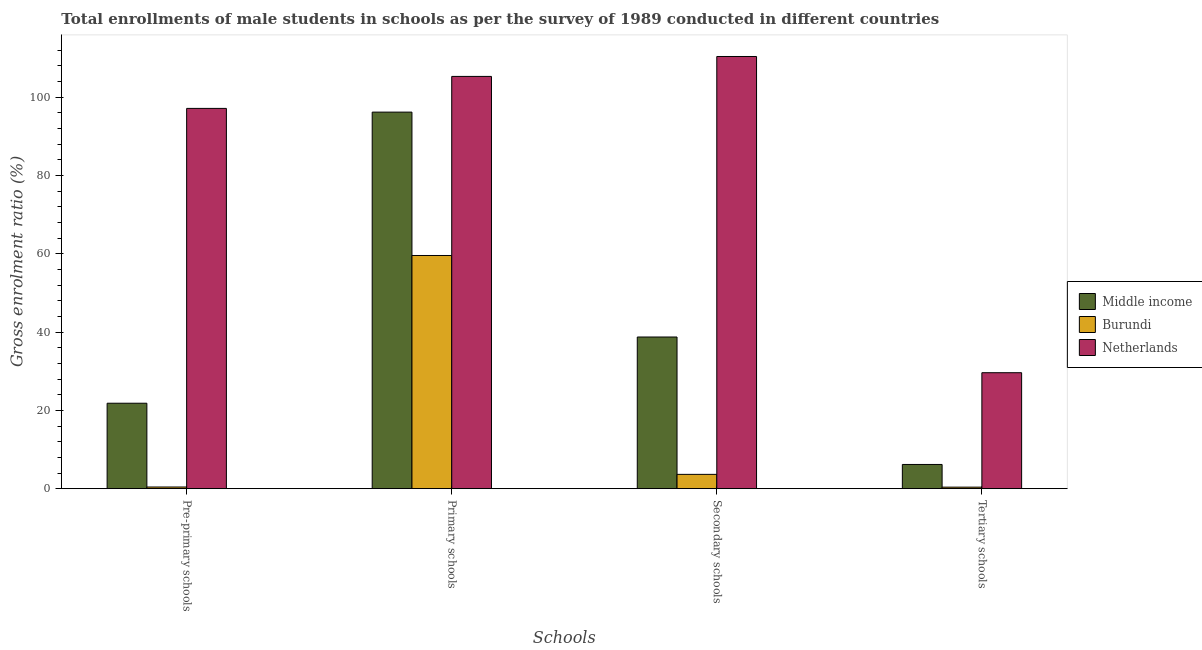How many different coloured bars are there?
Your answer should be very brief. 3. How many groups of bars are there?
Provide a short and direct response. 4. Are the number of bars per tick equal to the number of legend labels?
Your answer should be compact. Yes. Are the number of bars on each tick of the X-axis equal?
Ensure brevity in your answer.  Yes. How many bars are there on the 2nd tick from the left?
Make the answer very short. 3. How many bars are there on the 2nd tick from the right?
Offer a terse response. 3. What is the label of the 4th group of bars from the left?
Provide a short and direct response. Tertiary schools. What is the gross enrolment ratio(male) in pre-primary schools in Burundi?
Your answer should be very brief. 0.43. Across all countries, what is the maximum gross enrolment ratio(male) in pre-primary schools?
Give a very brief answer. 97.11. Across all countries, what is the minimum gross enrolment ratio(male) in secondary schools?
Your answer should be very brief. 3.65. In which country was the gross enrolment ratio(male) in secondary schools maximum?
Offer a terse response. Netherlands. In which country was the gross enrolment ratio(male) in tertiary schools minimum?
Give a very brief answer. Burundi. What is the total gross enrolment ratio(male) in tertiary schools in the graph?
Your answer should be very brief. 36.19. What is the difference between the gross enrolment ratio(male) in secondary schools in Netherlands and that in Burundi?
Offer a terse response. 106.71. What is the difference between the gross enrolment ratio(male) in tertiary schools in Burundi and the gross enrolment ratio(male) in secondary schools in Netherlands?
Provide a succinct answer. -109.97. What is the average gross enrolment ratio(male) in tertiary schools per country?
Provide a succinct answer. 12.06. What is the difference between the gross enrolment ratio(male) in secondary schools and gross enrolment ratio(male) in primary schools in Middle income?
Ensure brevity in your answer.  -57.43. In how many countries, is the gross enrolment ratio(male) in pre-primary schools greater than 8 %?
Your answer should be very brief. 2. What is the ratio of the gross enrolment ratio(male) in secondary schools in Middle income to that in Burundi?
Offer a very short reply. 10.6. What is the difference between the highest and the second highest gross enrolment ratio(male) in pre-primary schools?
Keep it short and to the point. 75.29. What is the difference between the highest and the lowest gross enrolment ratio(male) in primary schools?
Offer a terse response. 45.73. Is the sum of the gross enrolment ratio(male) in pre-primary schools in Burundi and Middle income greater than the maximum gross enrolment ratio(male) in tertiary schools across all countries?
Your response must be concise. No. Is it the case that in every country, the sum of the gross enrolment ratio(male) in pre-primary schools and gross enrolment ratio(male) in primary schools is greater than the gross enrolment ratio(male) in secondary schools?
Ensure brevity in your answer.  Yes. How many bars are there?
Keep it short and to the point. 12. How many countries are there in the graph?
Your response must be concise. 3. Are the values on the major ticks of Y-axis written in scientific E-notation?
Your answer should be compact. No. How many legend labels are there?
Ensure brevity in your answer.  3. What is the title of the graph?
Offer a terse response. Total enrollments of male students in schools as per the survey of 1989 conducted in different countries. What is the label or title of the X-axis?
Ensure brevity in your answer.  Schools. What is the Gross enrolment ratio (%) of Middle income in Pre-primary schools?
Ensure brevity in your answer.  21.82. What is the Gross enrolment ratio (%) of Burundi in Pre-primary schools?
Offer a terse response. 0.43. What is the Gross enrolment ratio (%) in Netherlands in Pre-primary schools?
Make the answer very short. 97.11. What is the Gross enrolment ratio (%) in Middle income in Primary schools?
Offer a terse response. 96.16. What is the Gross enrolment ratio (%) of Burundi in Primary schools?
Your answer should be compact. 59.55. What is the Gross enrolment ratio (%) in Netherlands in Primary schools?
Offer a very short reply. 105.28. What is the Gross enrolment ratio (%) in Middle income in Secondary schools?
Ensure brevity in your answer.  38.73. What is the Gross enrolment ratio (%) in Burundi in Secondary schools?
Your answer should be compact. 3.65. What is the Gross enrolment ratio (%) of Netherlands in Secondary schools?
Provide a succinct answer. 110.36. What is the Gross enrolment ratio (%) of Middle income in Tertiary schools?
Ensure brevity in your answer.  6.18. What is the Gross enrolment ratio (%) in Burundi in Tertiary schools?
Provide a succinct answer. 0.39. What is the Gross enrolment ratio (%) of Netherlands in Tertiary schools?
Offer a very short reply. 29.61. Across all Schools, what is the maximum Gross enrolment ratio (%) in Middle income?
Keep it short and to the point. 96.16. Across all Schools, what is the maximum Gross enrolment ratio (%) in Burundi?
Ensure brevity in your answer.  59.55. Across all Schools, what is the maximum Gross enrolment ratio (%) of Netherlands?
Provide a short and direct response. 110.36. Across all Schools, what is the minimum Gross enrolment ratio (%) of Middle income?
Ensure brevity in your answer.  6.18. Across all Schools, what is the minimum Gross enrolment ratio (%) of Burundi?
Your answer should be very brief. 0.39. Across all Schools, what is the minimum Gross enrolment ratio (%) of Netherlands?
Your response must be concise. 29.61. What is the total Gross enrolment ratio (%) in Middle income in the graph?
Your answer should be very brief. 162.89. What is the total Gross enrolment ratio (%) in Burundi in the graph?
Ensure brevity in your answer.  64.02. What is the total Gross enrolment ratio (%) in Netherlands in the graph?
Provide a short and direct response. 342.36. What is the difference between the Gross enrolment ratio (%) of Middle income in Pre-primary schools and that in Primary schools?
Your answer should be very brief. -74.34. What is the difference between the Gross enrolment ratio (%) in Burundi in Pre-primary schools and that in Primary schools?
Offer a terse response. -59.12. What is the difference between the Gross enrolment ratio (%) of Netherlands in Pre-primary schools and that in Primary schools?
Ensure brevity in your answer.  -8.17. What is the difference between the Gross enrolment ratio (%) in Middle income in Pre-primary schools and that in Secondary schools?
Offer a very short reply. -16.91. What is the difference between the Gross enrolment ratio (%) in Burundi in Pre-primary schools and that in Secondary schools?
Keep it short and to the point. -3.23. What is the difference between the Gross enrolment ratio (%) in Netherlands in Pre-primary schools and that in Secondary schools?
Ensure brevity in your answer.  -13.26. What is the difference between the Gross enrolment ratio (%) in Middle income in Pre-primary schools and that in Tertiary schools?
Your answer should be compact. 15.64. What is the difference between the Gross enrolment ratio (%) in Burundi in Pre-primary schools and that in Tertiary schools?
Offer a terse response. 0.04. What is the difference between the Gross enrolment ratio (%) of Netherlands in Pre-primary schools and that in Tertiary schools?
Provide a short and direct response. 67.49. What is the difference between the Gross enrolment ratio (%) in Middle income in Primary schools and that in Secondary schools?
Ensure brevity in your answer.  57.43. What is the difference between the Gross enrolment ratio (%) in Burundi in Primary schools and that in Secondary schools?
Your answer should be very brief. 55.89. What is the difference between the Gross enrolment ratio (%) in Netherlands in Primary schools and that in Secondary schools?
Make the answer very short. -5.09. What is the difference between the Gross enrolment ratio (%) in Middle income in Primary schools and that in Tertiary schools?
Make the answer very short. 89.98. What is the difference between the Gross enrolment ratio (%) in Burundi in Primary schools and that in Tertiary schools?
Your answer should be very brief. 59.16. What is the difference between the Gross enrolment ratio (%) in Netherlands in Primary schools and that in Tertiary schools?
Your response must be concise. 75.66. What is the difference between the Gross enrolment ratio (%) of Middle income in Secondary schools and that in Tertiary schools?
Offer a very short reply. 32.55. What is the difference between the Gross enrolment ratio (%) in Burundi in Secondary schools and that in Tertiary schools?
Make the answer very short. 3.26. What is the difference between the Gross enrolment ratio (%) of Netherlands in Secondary schools and that in Tertiary schools?
Your answer should be very brief. 80.75. What is the difference between the Gross enrolment ratio (%) in Middle income in Pre-primary schools and the Gross enrolment ratio (%) in Burundi in Primary schools?
Your answer should be very brief. -37.73. What is the difference between the Gross enrolment ratio (%) of Middle income in Pre-primary schools and the Gross enrolment ratio (%) of Netherlands in Primary schools?
Offer a very short reply. -83.45. What is the difference between the Gross enrolment ratio (%) of Burundi in Pre-primary schools and the Gross enrolment ratio (%) of Netherlands in Primary schools?
Your response must be concise. -104.85. What is the difference between the Gross enrolment ratio (%) in Middle income in Pre-primary schools and the Gross enrolment ratio (%) in Burundi in Secondary schools?
Provide a short and direct response. 18.17. What is the difference between the Gross enrolment ratio (%) in Middle income in Pre-primary schools and the Gross enrolment ratio (%) in Netherlands in Secondary schools?
Your response must be concise. -88.54. What is the difference between the Gross enrolment ratio (%) in Burundi in Pre-primary schools and the Gross enrolment ratio (%) in Netherlands in Secondary schools?
Your answer should be compact. -109.94. What is the difference between the Gross enrolment ratio (%) in Middle income in Pre-primary schools and the Gross enrolment ratio (%) in Burundi in Tertiary schools?
Keep it short and to the point. 21.43. What is the difference between the Gross enrolment ratio (%) in Middle income in Pre-primary schools and the Gross enrolment ratio (%) in Netherlands in Tertiary schools?
Provide a short and direct response. -7.79. What is the difference between the Gross enrolment ratio (%) in Burundi in Pre-primary schools and the Gross enrolment ratio (%) in Netherlands in Tertiary schools?
Provide a succinct answer. -29.19. What is the difference between the Gross enrolment ratio (%) of Middle income in Primary schools and the Gross enrolment ratio (%) of Burundi in Secondary schools?
Your answer should be very brief. 92.51. What is the difference between the Gross enrolment ratio (%) in Middle income in Primary schools and the Gross enrolment ratio (%) in Netherlands in Secondary schools?
Offer a very short reply. -14.21. What is the difference between the Gross enrolment ratio (%) in Burundi in Primary schools and the Gross enrolment ratio (%) in Netherlands in Secondary schools?
Provide a short and direct response. -50.82. What is the difference between the Gross enrolment ratio (%) of Middle income in Primary schools and the Gross enrolment ratio (%) of Burundi in Tertiary schools?
Your answer should be very brief. 95.77. What is the difference between the Gross enrolment ratio (%) in Middle income in Primary schools and the Gross enrolment ratio (%) in Netherlands in Tertiary schools?
Ensure brevity in your answer.  66.54. What is the difference between the Gross enrolment ratio (%) of Burundi in Primary schools and the Gross enrolment ratio (%) of Netherlands in Tertiary schools?
Your answer should be compact. 29.93. What is the difference between the Gross enrolment ratio (%) of Middle income in Secondary schools and the Gross enrolment ratio (%) of Burundi in Tertiary schools?
Offer a terse response. 38.34. What is the difference between the Gross enrolment ratio (%) of Middle income in Secondary schools and the Gross enrolment ratio (%) of Netherlands in Tertiary schools?
Your answer should be very brief. 9.12. What is the difference between the Gross enrolment ratio (%) in Burundi in Secondary schools and the Gross enrolment ratio (%) in Netherlands in Tertiary schools?
Ensure brevity in your answer.  -25.96. What is the average Gross enrolment ratio (%) of Middle income per Schools?
Offer a very short reply. 40.72. What is the average Gross enrolment ratio (%) in Burundi per Schools?
Keep it short and to the point. 16. What is the average Gross enrolment ratio (%) of Netherlands per Schools?
Provide a succinct answer. 85.59. What is the difference between the Gross enrolment ratio (%) of Middle income and Gross enrolment ratio (%) of Burundi in Pre-primary schools?
Give a very brief answer. 21.39. What is the difference between the Gross enrolment ratio (%) in Middle income and Gross enrolment ratio (%) in Netherlands in Pre-primary schools?
Offer a terse response. -75.29. What is the difference between the Gross enrolment ratio (%) of Burundi and Gross enrolment ratio (%) of Netherlands in Pre-primary schools?
Provide a succinct answer. -96.68. What is the difference between the Gross enrolment ratio (%) in Middle income and Gross enrolment ratio (%) in Burundi in Primary schools?
Provide a succinct answer. 36.61. What is the difference between the Gross enrolment ratio (%) in Middle income and Gross enrolment ratio (%) in Netherlands in Primary schools?
Make the answer very short. -9.12. What is the difference between the Gross enrolment ratio (%) of Burundi and Gross enrolment ratio (%) of Netherlands in Primary schools?
Provide a succinct answer. -45.73. What is the difference between the Gross enrolment ratio (%) in Middle income and Gross enrolment ratio (%) in Burundi in Secondary schools?
Provide a short and direct response. 35.08. What is the difference between the Gross enrolment ratio (%) in Middle income and Gross enrolment ratio (%) in Netherlands in Secondary schools?
Make the answer very short. -71.63. What is the difference between the Gross enrolment ratio (%) of Burundi and Gross enrolment ratio (%) of Netherlands in Secondary schools?
Ensure brevity in your answer.  -106.71. What is the difference between the Gross enrolment ratio (%) in Middle income and Gross enrolment ratio (%) in Burundi in Tertiary schools?
Keep it short and to the point. 5.79. What is the difference between the Gross enrolment ratio (%) of Middle income and Gross enrolment ratio (%) of Netherlands in Tertiary schools?
Offer a terse response. -23.43. What is the difference between the Gross enrolment ratio (%) in Burundi and Gross enrolment ratio (%) in Netherlands in Tertiary schools?
Your response must be concise. -29.22. What is the ratio of the Gross enrolment ratio (%) of Middle income in Pre-primary schools to that in Primary schools?
Provide a succinct answer. 0.23. What is the ratio of the Gross enrolment ratio (%) of Burundi in Pre-primary schools to that in Primary schools?
Ensure brevity in your answer.  0.01. What is the ratio of the Gross enrolment ratio (%) in Netherlands in Pre-primary schools to that in Primary schools?
Your answer should be very brief. 0.92. What is the ratio of the Gross enrolment ratio (%) of Middle income in Pre-primary schools to that in Secondary schools?
Ensure brevity in your answer.  0.56. What is the ratio of the Gross enrolment ratio (%) of Burundi in Pre-primary schools to that in Secondary schools?
Your response must be concise. 0.12. What is the ratio of the Gross enrolment ratio (%) in Netherlands in Pre-primary schools to that in Secondary schools?
Provide a short and direct response. 0.88. What is the ratio of the Gross enrolment ratio (%) in Middle income in Pre-primary schools to that in Tertiary schools?
Provide a succinct answer. 3.53. What is the ratio of the Gross enrolment ratio (%) in Burundi in Pre-primary schools to that in Tertiary schools?
Give a very brief answer. 1.09. What is the ratio of the Gross enrolment ratio (%) in Netherlands in Pre-primary schools to that in Tertiary schools?
Provide a succinct answer. 3.28. What is the ratio of the Gross enrolment ratio (%) in Middle income in Primary schools to that in Secondary schools?
Your answer should be compact. 2.48. What is the ratio of the Gross enrolment ratio (%) in Burundi in Primary schools to that in Secondary schools?
Offer a very short reply. 16.3. What is the ratio of the Gross enrolment ratio (%) of Netherlands in Primary schools to that in Secondary schools?
Provide a short and direct response. 0.95. What is the ratio of the Gross enrolment ratio (%) of Middle income in Primary schools to that in Tertiary schools?
Offer a terse response. 15.55. What is the ratio of the Gross enrolment ratio (%) in Burundi in Primary schools to that in Tertiary schools?
Offer a very short reply. 152.78. What is the ratio of the Gross enrolment ratio (%) in Netherlands in Primary schools to that in Tertiary schools?
Make the answer very short. 3.55. What is the ratio of the Gross enrolment ratio (%) of Middle income in Secondary schools to that in Tertiary schools?
Your response must be concise. 6.27. What is the ratio of the Gross enrolment ratio (%) in Burundi in Secondary schools to that in Tertiary schools?
Offer a terse response. 9.37. What is the ratio of the Gross enrolment ratio (%) of Netherlands in Secondary schools to that in Tertiary schools?
Ensure brevity in your answer.  3.73. What is the difference between the highest and the second highest Gross enrolment ratio (%) of Middle income?
Keep it short and to the point. 57.43. What is the difference between the highest and the second highest Gross enrolment ratio (%) of Burundi?
Keep it short and to the point. 55.89. What is the difference between the highest and the second highest Gross enrolment ratio (%) of Netherlands?
Keep it short and to the point. 5.09. What is the difference between the highest and the lowest Gross enrolment ratio (%) in Middle income?
Your answer should be compact. 89.98. What is the difference between the highest and the lowest Gross enrolment ratio (%) of Burundi?
Make the answer very short. 59.16. What is the difference between the highest and the lowest Gross enrolment ratio (%) in Netherlands?
Your answer should be compact. 80.75. 